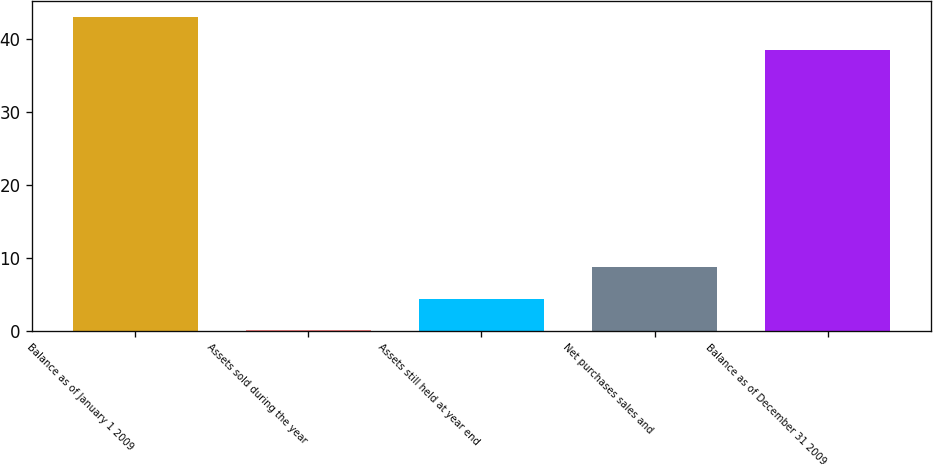<chart> <loc_0><loc_0><loc_500><loc_500><bar_chart><fcel>Balance as of January 1 2009<fcel>Assets sold during the year<fcel>Assets still held at year end<fcel>Net purchases sales and<fcel>Balance as of December 31 2009<nl><fcel>43.1<fcel>0.1<fcel>4.4<fcel>8.7<fcel>38.6<nl></chart> 